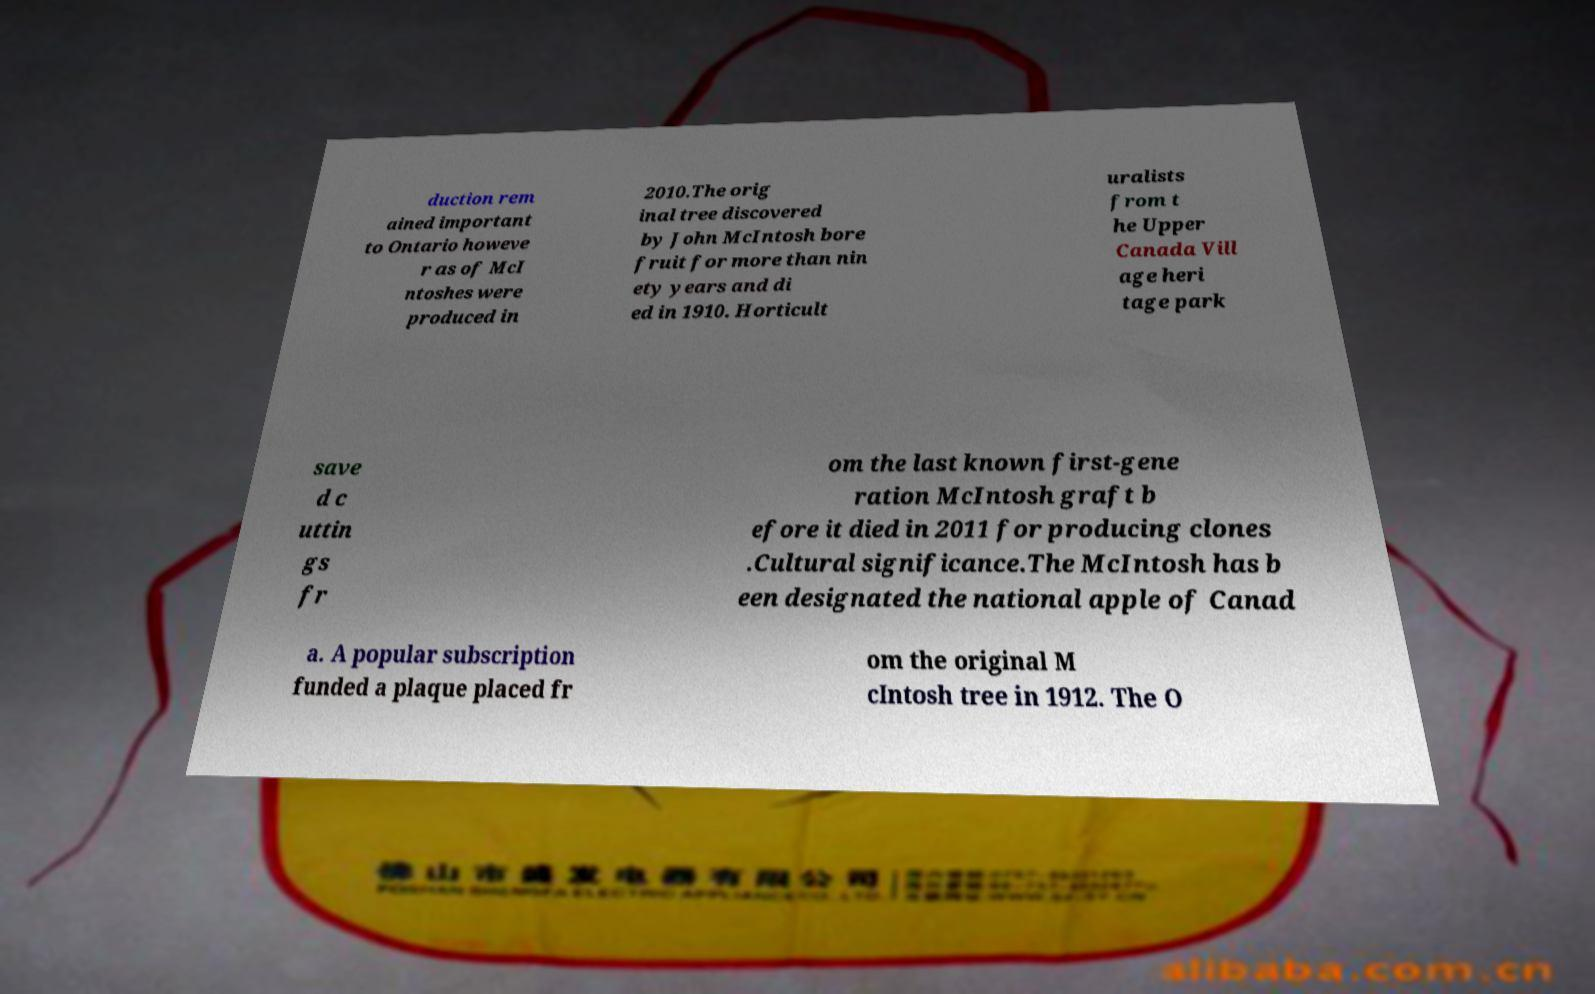What messages or text are displayed in this image? I need them in a readable, typed format. duction rem ained important to Ontario howeve r as of McI ntoshes were produced in 2010.The orig inal tree discovered by John McIntosh bore fruit for more than nin ety years and di ed in 1910. Horticult uralists from t he Upper Canada Vill age heri tage park save d c uttin gs fr om the last known first-gene ration McIntosh graft b efore it died in 2011 for producing clones .Cultural significance.The McIntosh has b een designated the national apple of Canad a. A popular subscription funded a plaque placed fr om the original M cIntosh tree in 1912. The O 